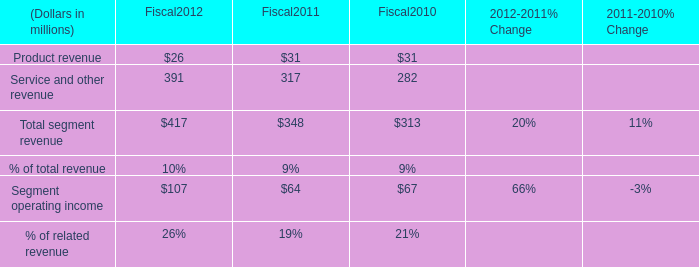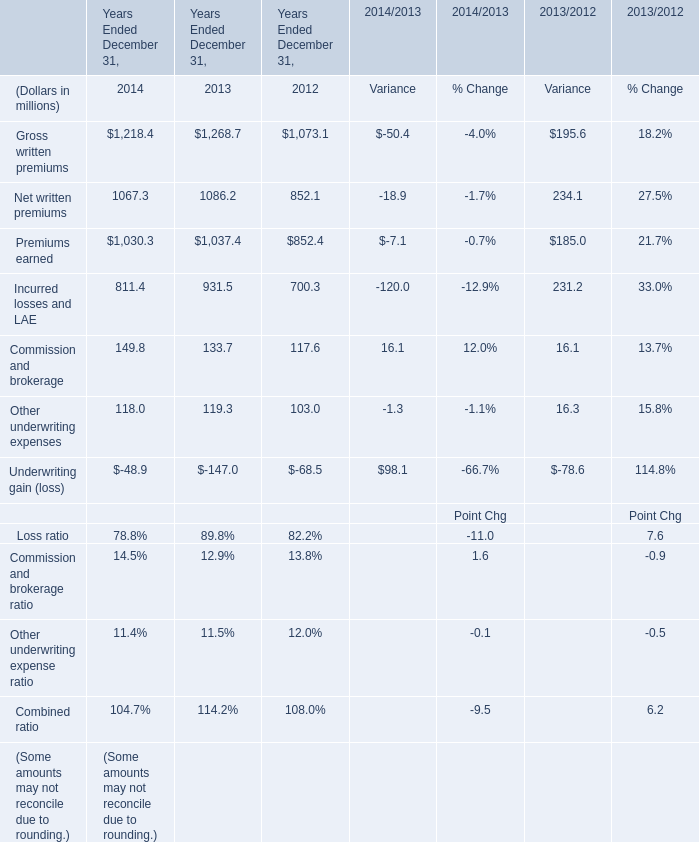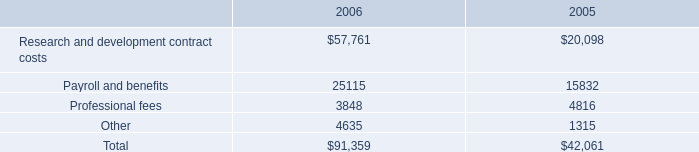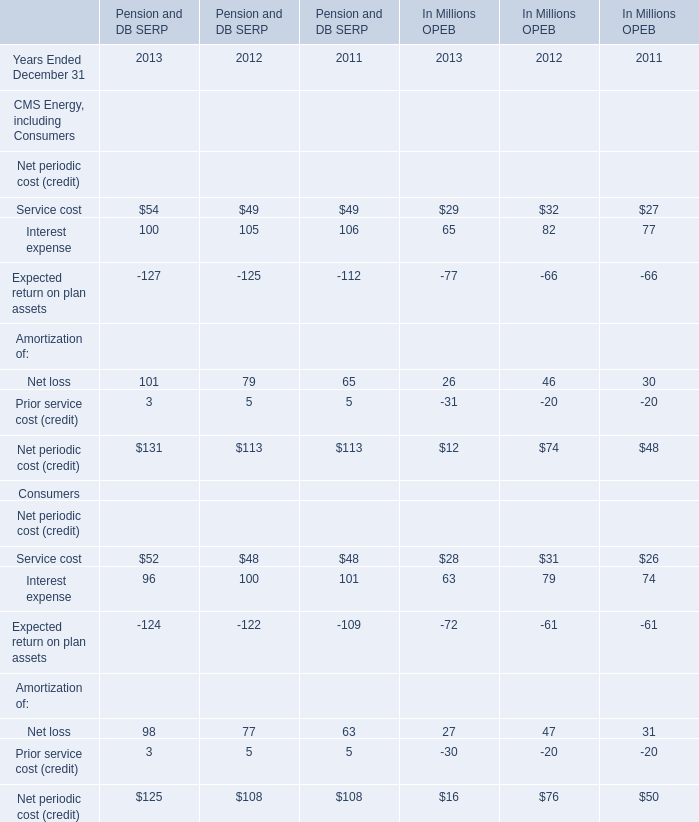What's the average of Payroll and benefits of 2006, and Net written premiums of Years Ended December 31, 2014 ? 
Computations: ((25115.0 + 1067.3) / 2)
Answer: 13091.15. 